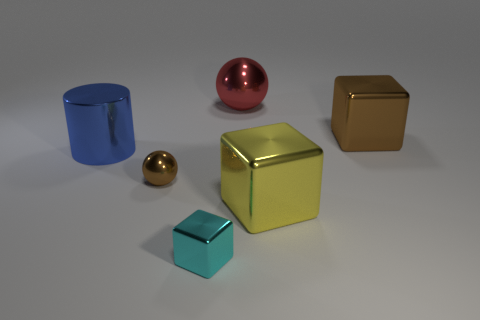Add 3 big spheres. How many objects exist? 9 Subtract all large metallic cubes. How many cubes are left? 1 Subtract 1 blocks. How many blocks are left? 2 Subtract all cylinders. How many objects are left? 5 Subtract all red metal objects. Subtract all big blue shiny cylinders. How many objects are left? 4 Add 2 large objects. How many large objects are left? 6 Add 1 big brown objects. How many big brown objects exist? 2 Subtract 0 purple spheres. How many objects are left? 6 Subtract all purple spheres. Subtract all cyan blocks. How many spheres are left? 2 